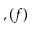<formula> <loc_0><loc_0><loc_500><loc_500>, ( f )</formula> 